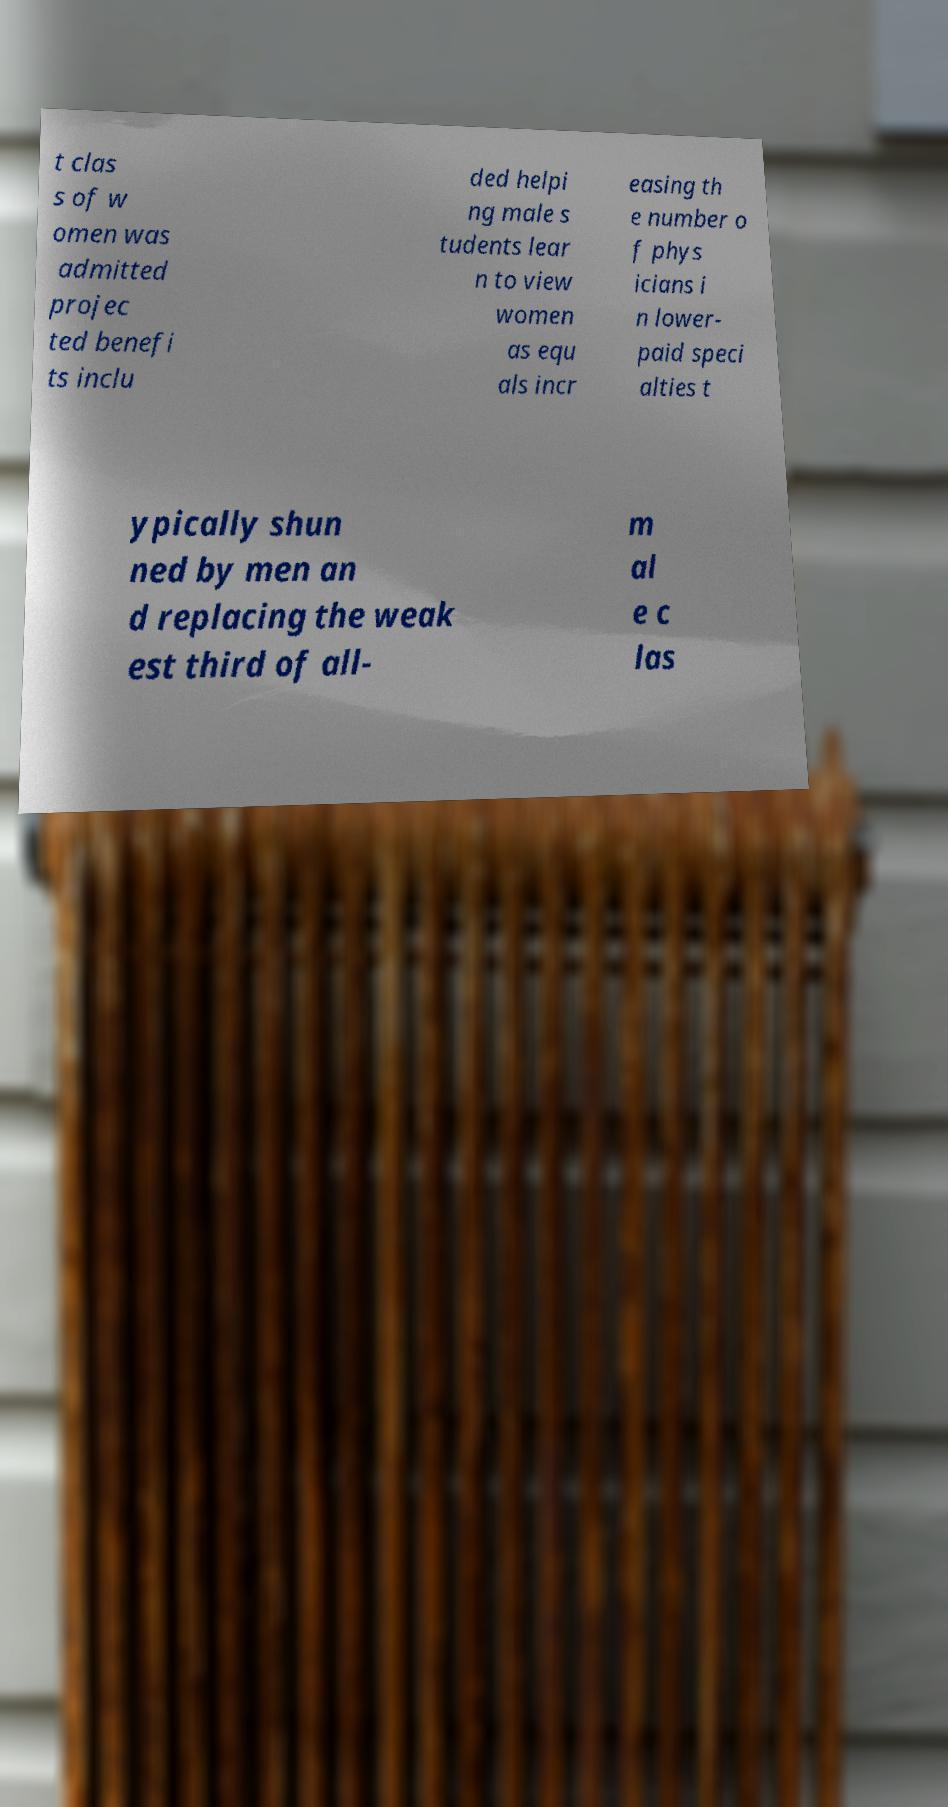What messages or text are displayed in this image? I need them in a readable, typed format. t clas s of w omen was admitted projec ted benefi ts inclu ded helpi ng male s tudents lear n to view women as equ als incr easing th e number o f phys icians i n lower- paid speci alties t ypically shun ned by men an d replacing the weak est third of all- m al e c las 